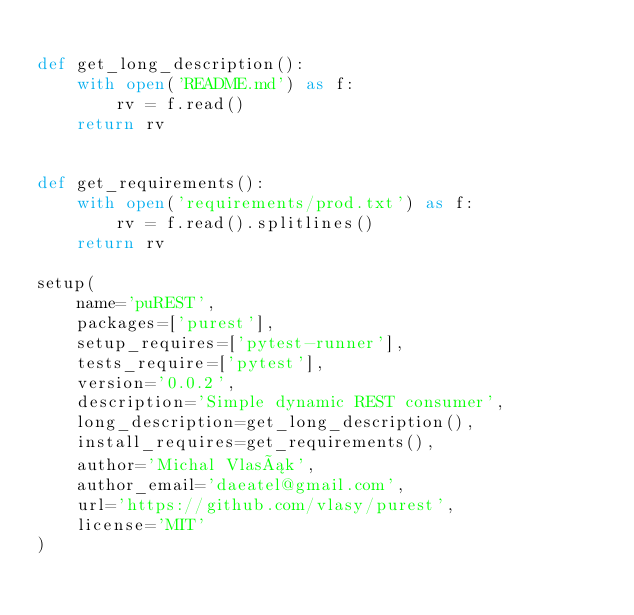Convert code to text. <code><loc_0><loc_0><loc_500><loc_500><_Python_>
def get_long_description():
    with open('README.md') as f:
        rv = f.read()
    return rv


def get_requirements():
    with open('requirements/prod.txt') as f:
        rv = f.read().splitlines()
    return rv

setup(
    name='puREST',
    packages=['purest'],
    setup_requires=['pytest-runner'],
    tests_require=['pytest'],
    version='0.0.2',
    description='Simple dynamic REST consumer',
    long_description=get_long_description(),
    install_requires=get_requirements(),
    author='Michal Vlasák',
    author_email='daeatel@gmail.com',
    url='https://github.com/vlasy/purest',
    license='MIT'
)
</code> 